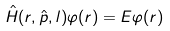<formula> <loc_0><loc_0><loc_500><loc_500>\hat { H } ( r , \hat { p } , l ) \varphi ( r ) = E \varphi ( r )</formula> 